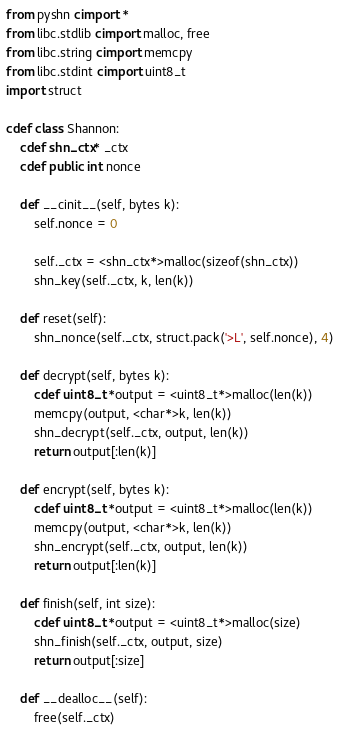<code> <loc_0><loc_0><loc_500><loc_500><_Cython_>from pyshn cimport *
from libc.stdlib cimport malloc, free
from libc.string cimport memcpy
from libc.stdint cimport uint8_t
import struct

cdef class Shannon:
    cdef shn_ctx* _ctx
    cdef public int nonce

    def __cinit__(self, bytes k):
        self.nonce = 0

        self._ctx = <shn_ctx*>malloc(sizeof(shn_ctx))
        shn_key(self._ctx, k, len(k))

    def reset(self):
        shn_nonce(self._ctx, struct.pack('>L', self.nonce), 4)

    def decrypt(self, bytes k):
        cdef uint8_t *output = <uint8_t*>malloc(len(k))
        memcpy(output, <char*>k, len(k))
        shn_decrypt(self._ctx, output, len(k))
        return output[:len(k)]

    def encrypt(self, bytes k):
        cdef uint8_t *output = <uint8_t*>malloc(len(k))
        memcpy(output, <char*>k, len(k))
        shn_encrypt(self._ctx, output, len(k))
        return output[:len(k)]

    def finish(self, int size):
        cdef uint8_t *output = <uint8_t*>malloc(size)
        shn_finish(self._ctx, output, size)
        return output[:size]

    def __dealloc__(self):
        free(self._ctx)

</code> 